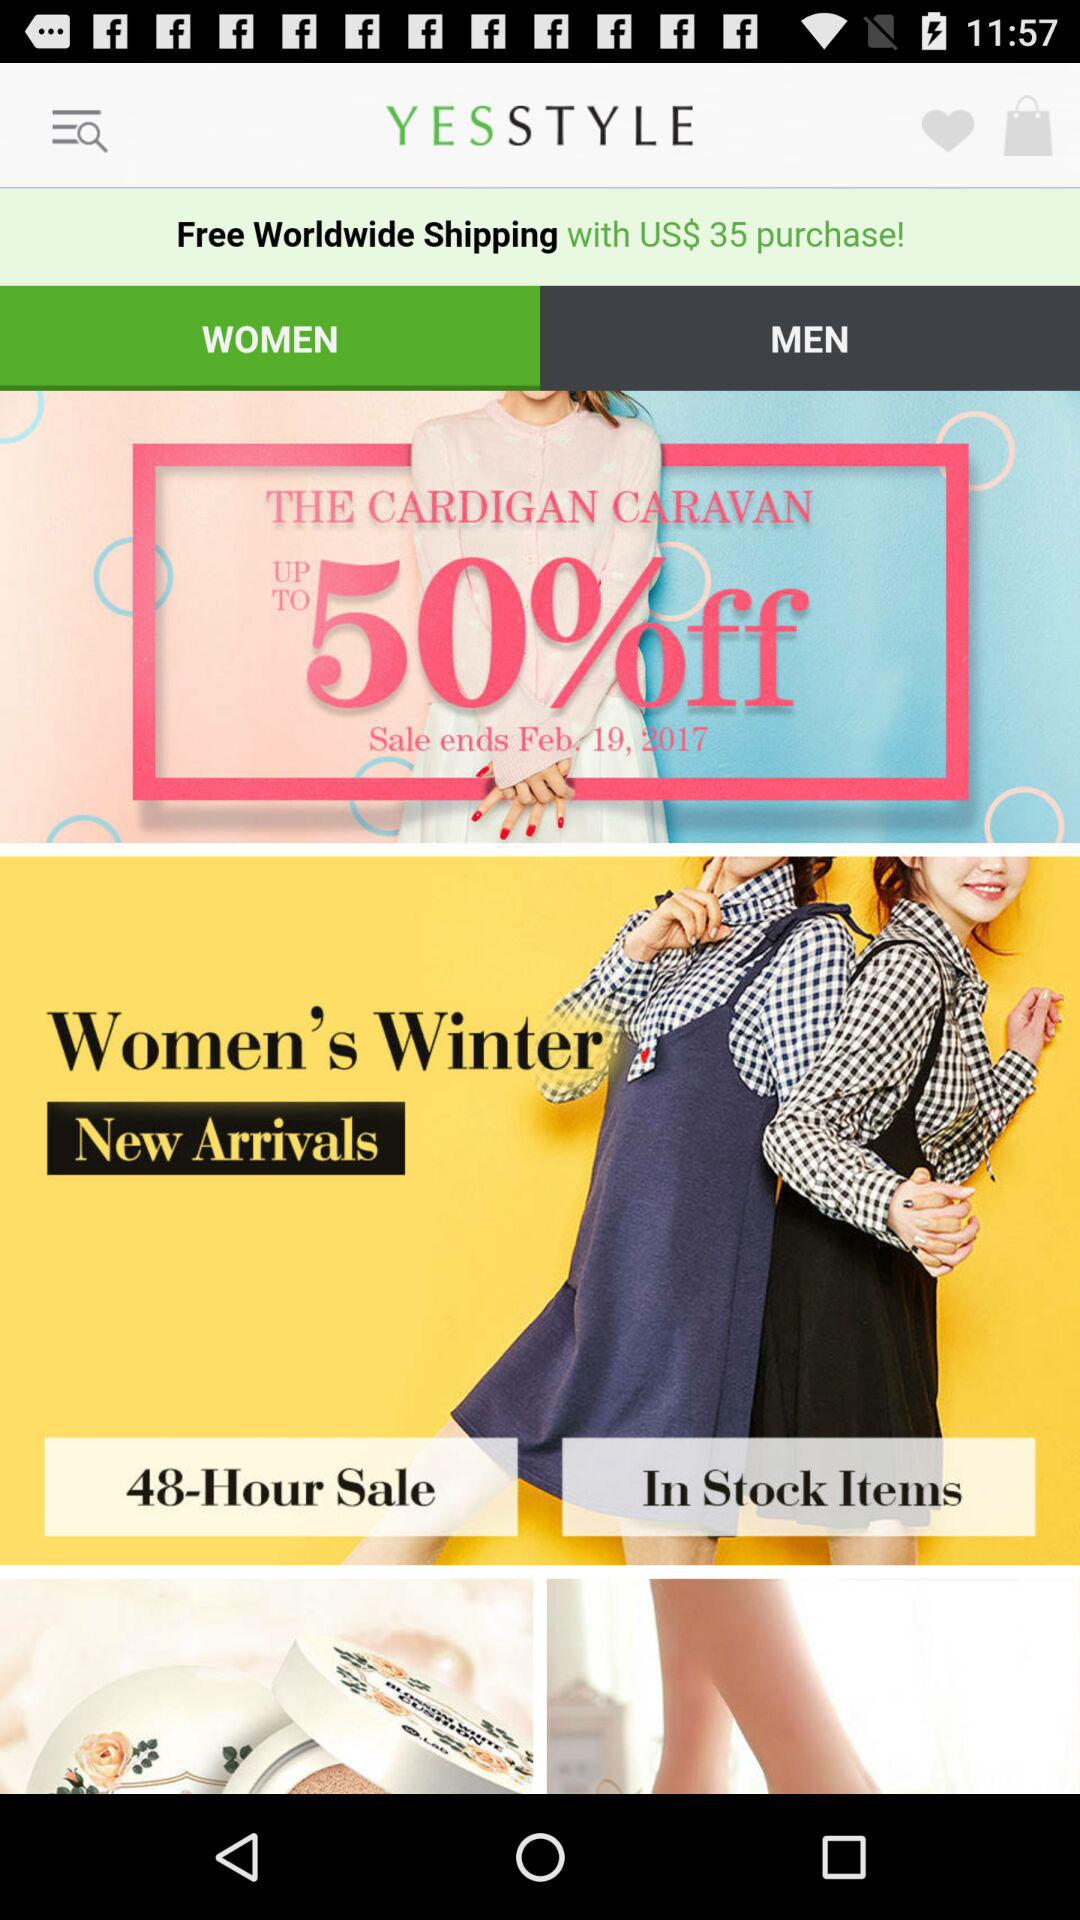What is the purchase amount to avail free worldwide shipping? The purchase amount to avail free worldwide shipping is US$ 35. 